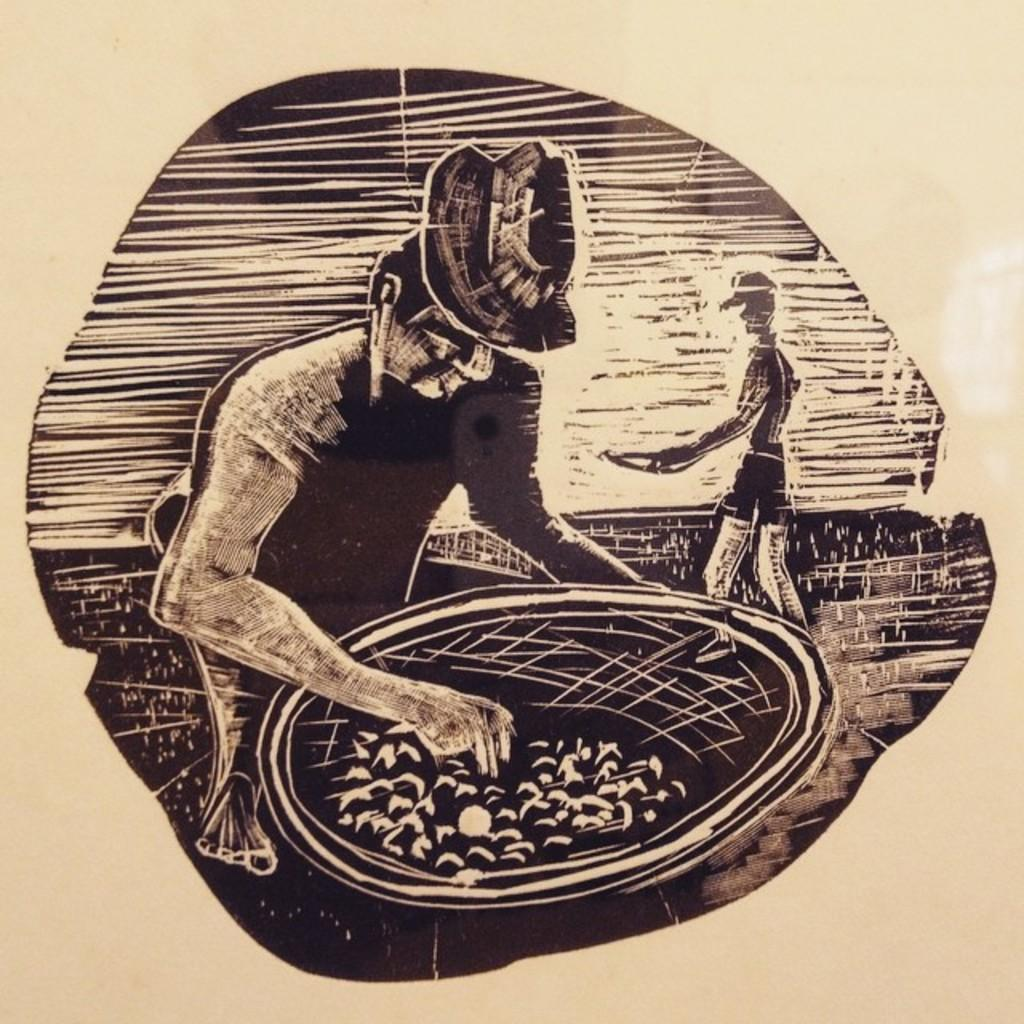What medium is used to create the image? The image is a sketch on paper. What is the main subject of the sketch? The sketch depicts a person holding an object. Can you describe the setting of the sketch? There is another person in the background of the sketch. What type of advice is the person in the foreground giving to the insect in the image? There is no insect present in the image, so no advice can be given. 